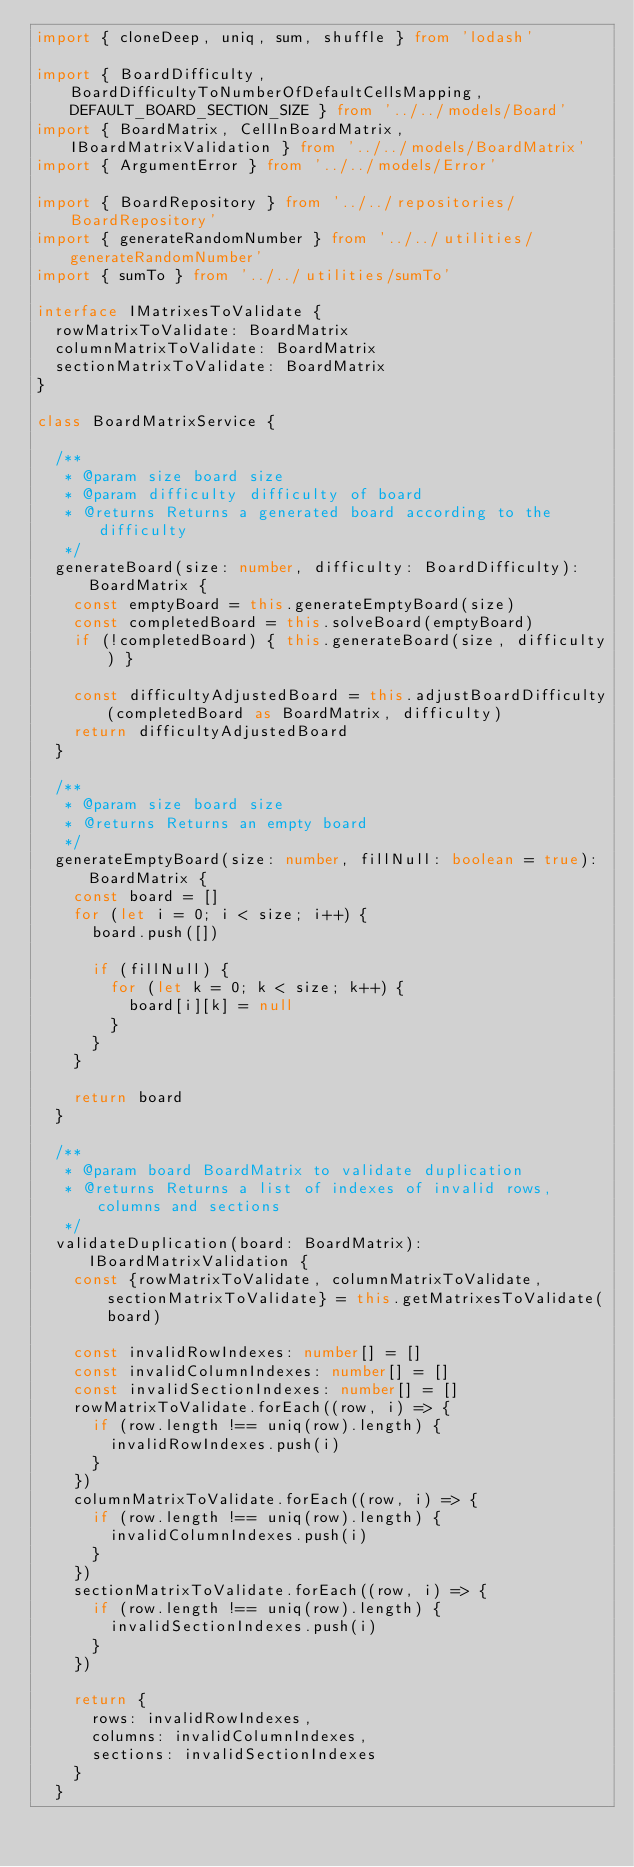<code> <loc_0><loc_0><loc_500><loc_500><_TypeScript_>import { cloneDeep, uniq, sum, shuffle } from 'lodash'

import { BoardDifficulty, BoardDifficultyToNumberOfDefaultCellsMapping, DEFAULT_BOARD_SECTION_SIZE } from '../../models/Board'
import { BoardMatrix, CellInBoardMatrix, IBoardMatrixValidation } from '../../models/BoardMatrix'
import { ArgumentError } from '../../models/Error'

import { BoardRepository } from '../../repositories/BoardRepository'
import { generateRandomNumber } from '../../utilities/generateRandomNumber'
import { sumTo } from '../../utilities/sumTo'

interface IMatrixesToValidate {
  rowMatrixToValidate: BoardMatrix
  columnMatrixToValidate: BoardMatrix
  sectionMatrixToValidate: BoardMatrix
}

class BoardMatrixService {

  /**
   * @param size board size
   * @param difficulty difficulty of board
   * @returns Returns a generated board according to the difficulty
   */
  generateBoard(size: number, difficulty: BoardDifficulty): BoardMatrix {
    const emptyBoard = this.generateEmptyBoard(size)
    const completedBoard = this.solveBoard(emptyBoard)
    if (!completedBoard) { this.generateBoard(size, difficulty) }

    const difficultyAdjustedBoard = this.adjustBoardDifficulty(completedBoard as BoardMatrix, difficulty)
    return difficultyAdjustedBoard
  }

  /**
   * @param size board size
   * @returns Returns an empty board
   */
  generateEmptyBoard(size: number, fillNull: boolean = true): BoardMatrix {
    const board = []
    for (let i = 0; i < size; i++) {
      board.push([])

      if (fillNull) {
        for (let k = 0; k < size; k++) {
          board[i][k] = null
        }
      }
    }

    return board
  }

  /**
   * @param board BoardMatrix to validate duplication
   * @returns Returns a list of indexes of invalid rows, columns and sections
   */
  validateDuplication(board: BoardMatrix): IBoardMatrixValidation {
    const {rowMatrixToValidate, columnMatrixToValidate, sectionMatrixToValidate} = this.getMatrixesToValidate(board)

    const invalidRowIndexes: number[] = []
    const invalidColumnIndexes: number[] = []
    const invalidSectionIndexes: number[] = []
    rowMatrixToValidate.forEach((row, i) => {
      if (row.length !== uniq(row).length) {
        invalidRowIndexes.push(i)
      }
    })
    columnMatrixToValidate.forEach((row, i) => {
      if (row.length !== uniq(row).length) {
        invalidColumnIndexes.push(i)
      }
    })
    sectionMatrixToValidate.forEach((row, i) => {
      if (row.length !== uniq(row).length) {
        invalidSectionIndexes.push(i)
      }
    })

    return {
      rows: invalidRowIndexes,
      columns: invalidColumnIndexes,
      sections: invalidSectionIndexes
    }
  }
</code> 